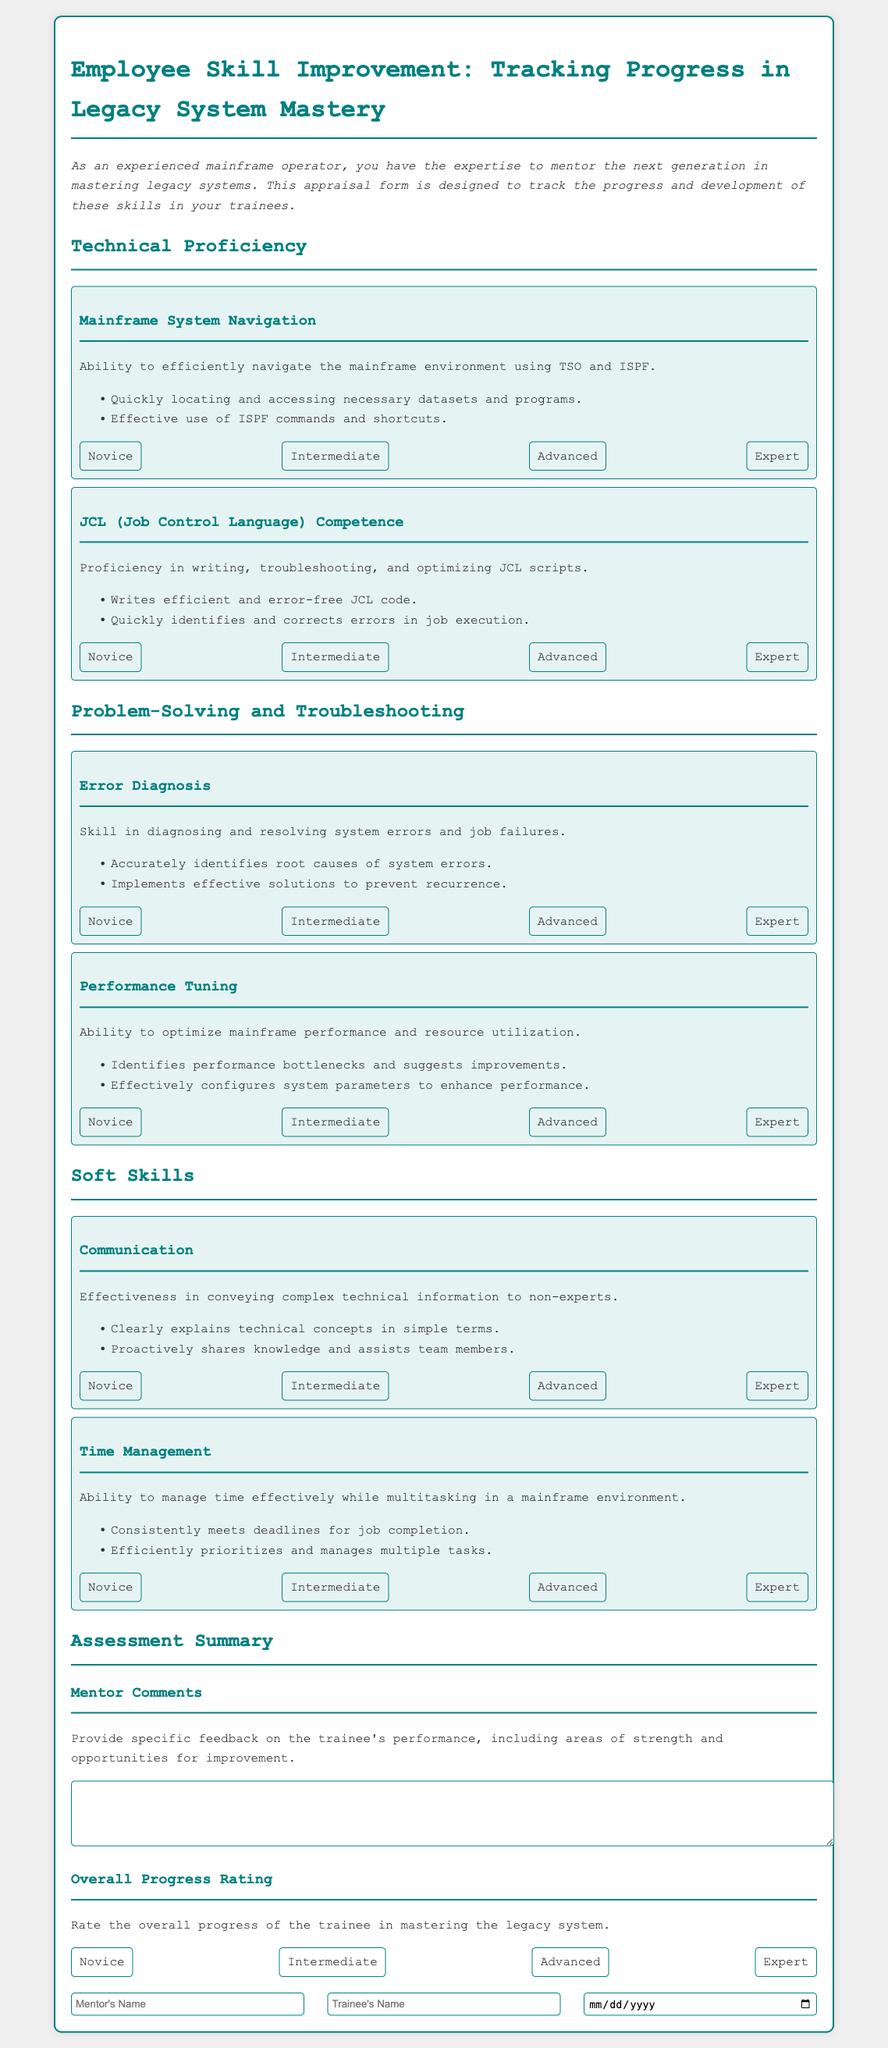What is the title of the appraisal form? The title provides the purpose of the document and is prominently displayed at the top.
Answer: Employee Skill Improvement: Tracking Progress in Legacy System Mastery What rating options are provided for Mainframe System Navigation? The document lists specific rating options for each skill section, which help in evaluating proficiency.
Answer: Novice, Intermediate, Advanced, Expert What is one of the skills listed under Problem-Solving and Troubleshooting? The document outlines specific skills related to problem-solving and troubleshooting in legacy systems.
Answer: Error Diagnosis In what section is "Time Management" located? The document is organized into sections, each focusing on different competencies and skills.
Answer: Soft Skills How many skills are assessed in the Technical Proficiency section? Count the individual skills listed in this section for accurate information.
Answer: 2 What specific type of feedback is requested for the Mentor Comments? The document requires mentors to provide specific feedback regarding trainee performance.
Answer: Specific feedback on performance What is the primary purpose of this appraisal form? Understanding the primary intent of the document helps clarify its use and importance.
Answer: To track the progress and development of skills in trainees What is the placeholder for the date input field? The document specifies input fields with placeholders, indicating the expected content format.
Answer: Date What should the mentor provide in the Overall Progress Rating section? This section asks for an overall assessment of trainee progress in mastering legacy systems.
Answer: A rating 